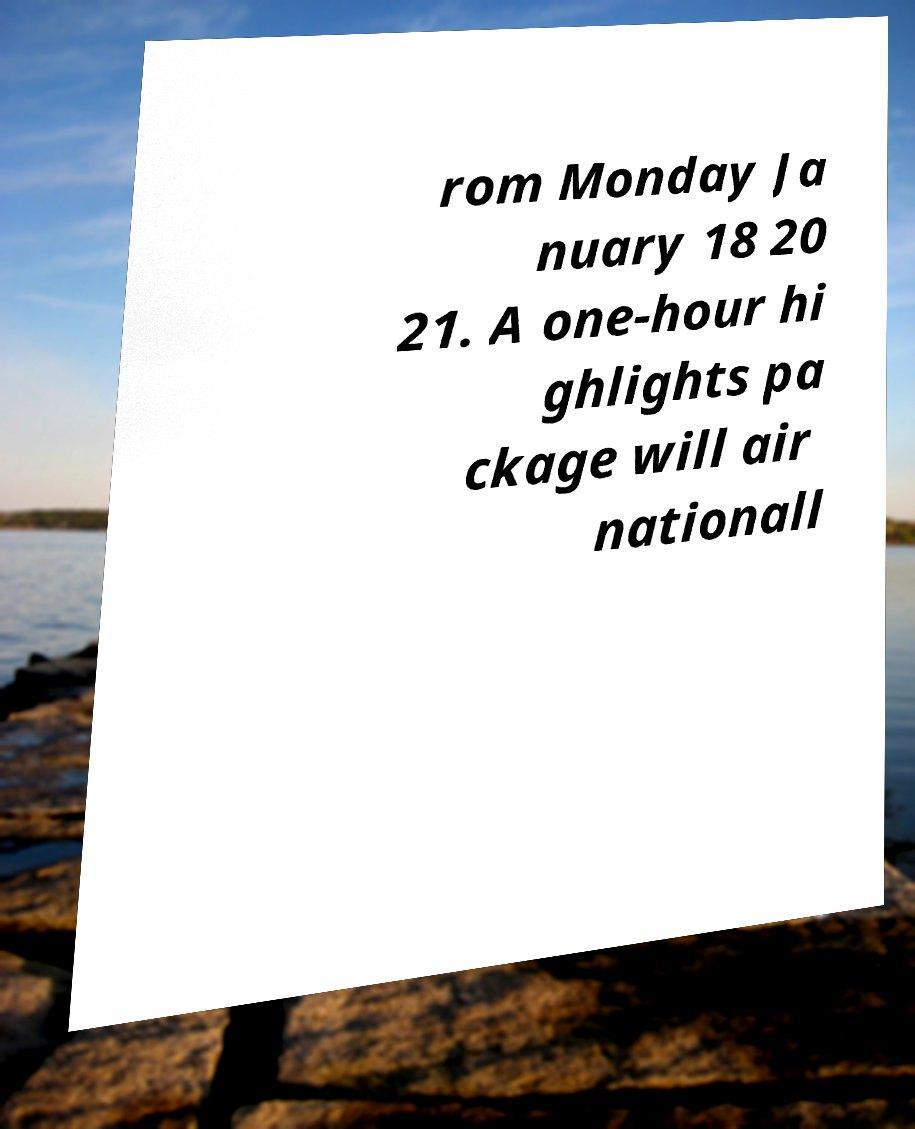Can you read and provide the text displayed in the image?This photo seems to have some interesting text. Can you extract and type it out for me? rom Monday Ja nuary 18 20 21. A one-hour hi ghlights pa ckage will air nationall 